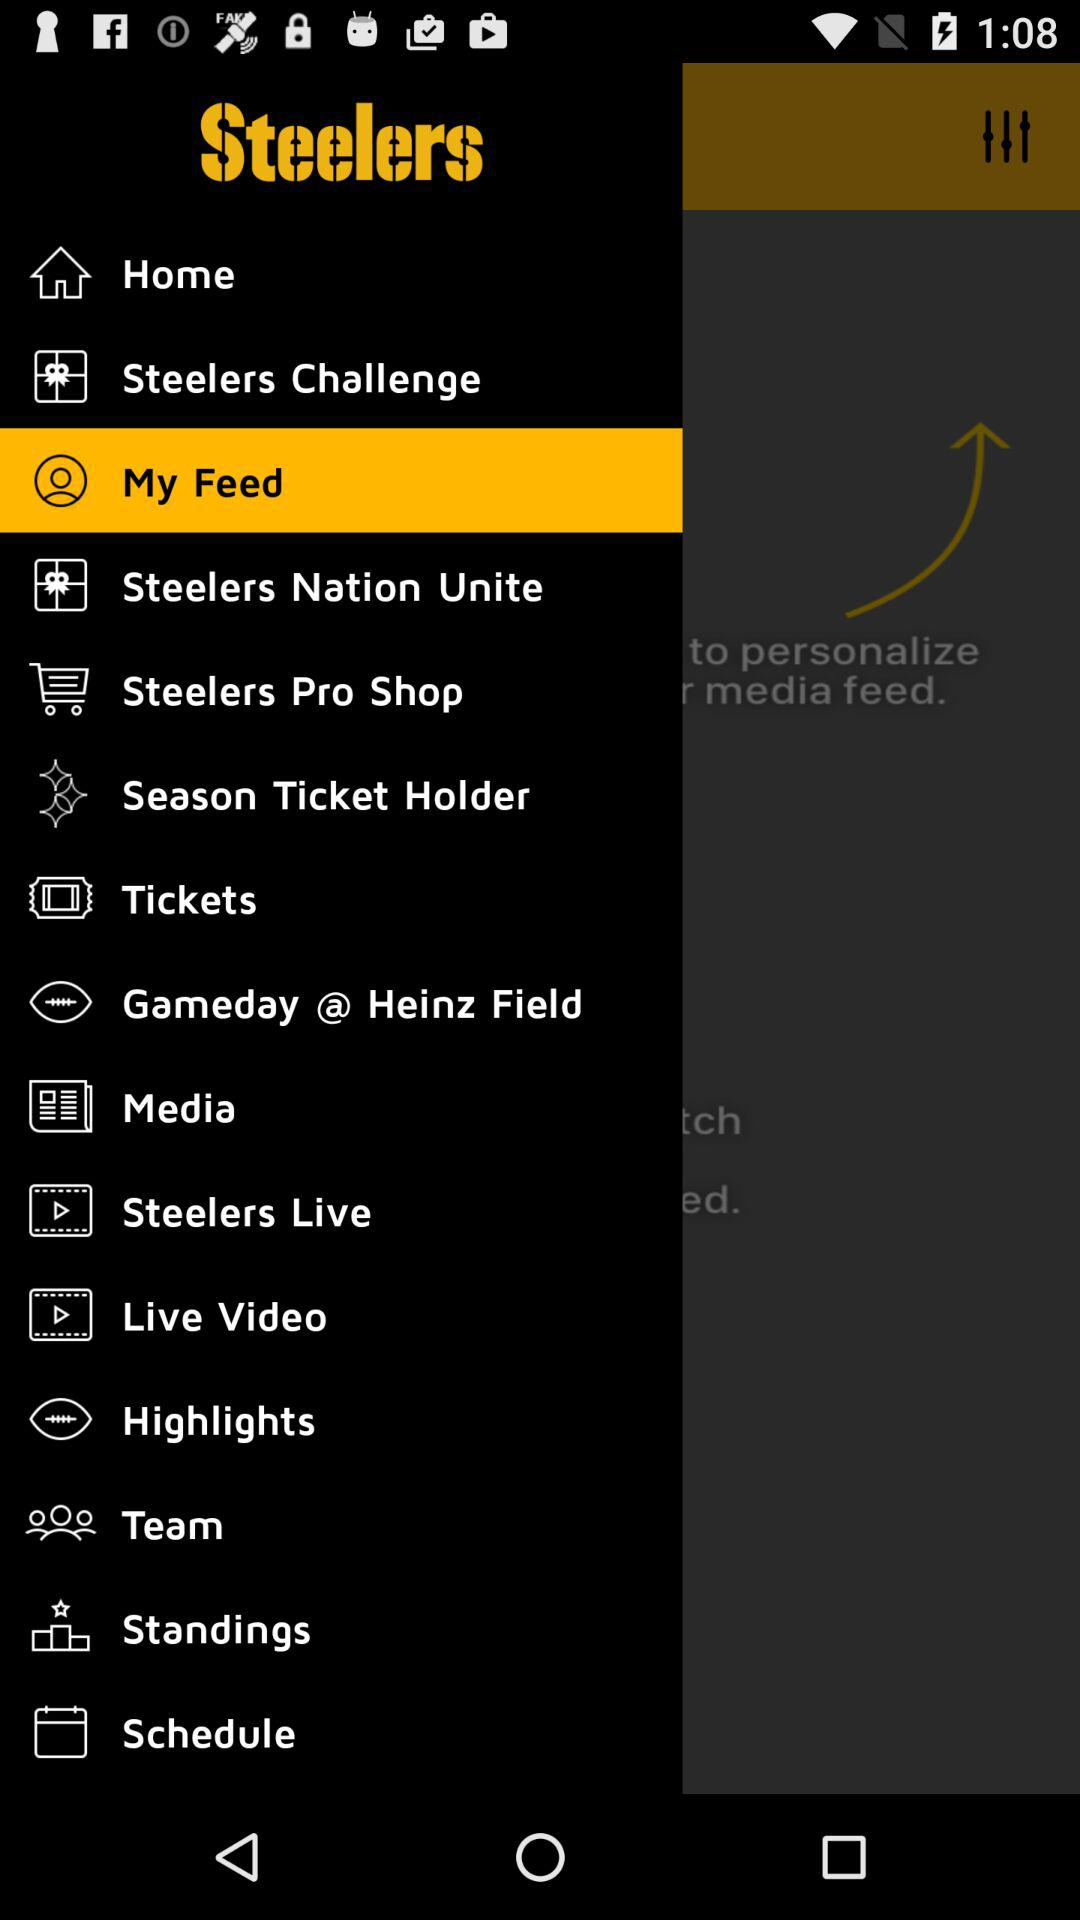Which is the selected item in the menu? The selected item in the menu is "My Feed". 